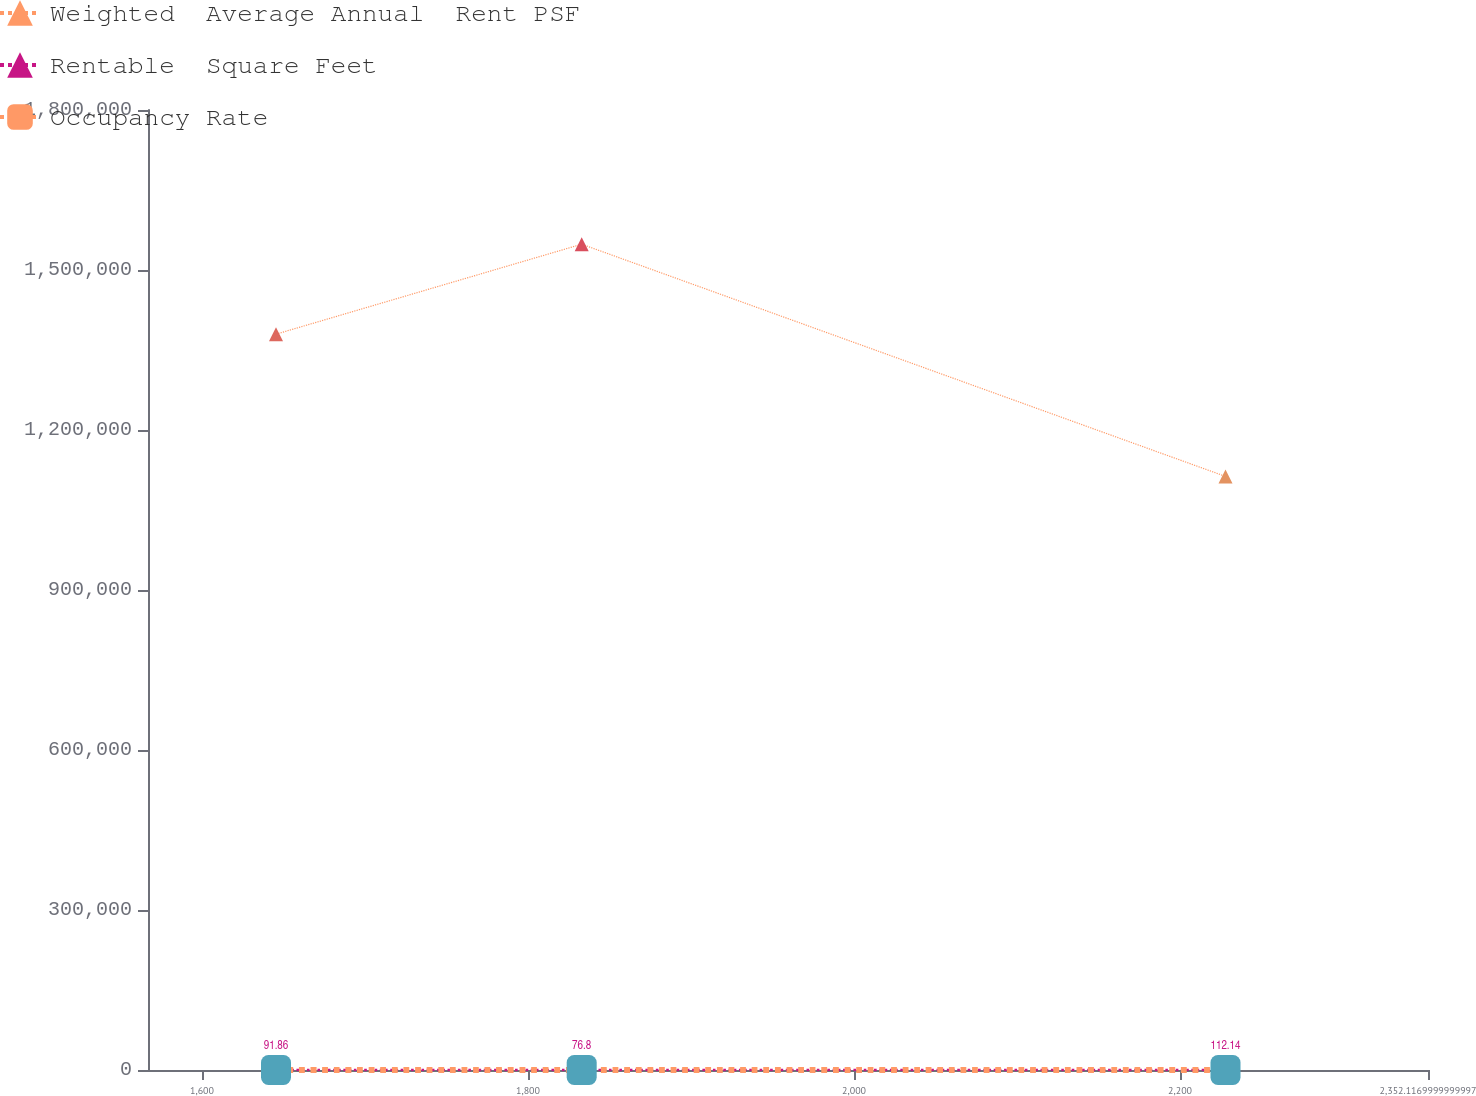Convert chart. <chart><loc_0><loc_0><loc_500><loc_500><line_chart><ecel><fcel>Weighted  Average Annual  Rent PSF<fcel>Rentable  Square Feet<fcel>Occupancy Rate<nl><fcel>1645.41<fcel>1.37967e+06<fcel>91.86<fcel>29.45<nl><fcel>1832.94<fcel>1.54838e+06<fcel>76.8<fcel>30.36<nl><fcel>2227.89<fcel>1.11296e+06<fcel>112.14<fcel>26.39<nl><fcel>2355.58<fcel>1.17622e+06<fcel>83.66<fcel>20.63<nl><fcel>2430.64<fcel>1.33613e+06<fcel>102.43<fcel>21.87<nl></chart> 